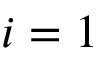<formula> <loc_0><loc_0><loc_500><loc_500>i = 1</formula> 